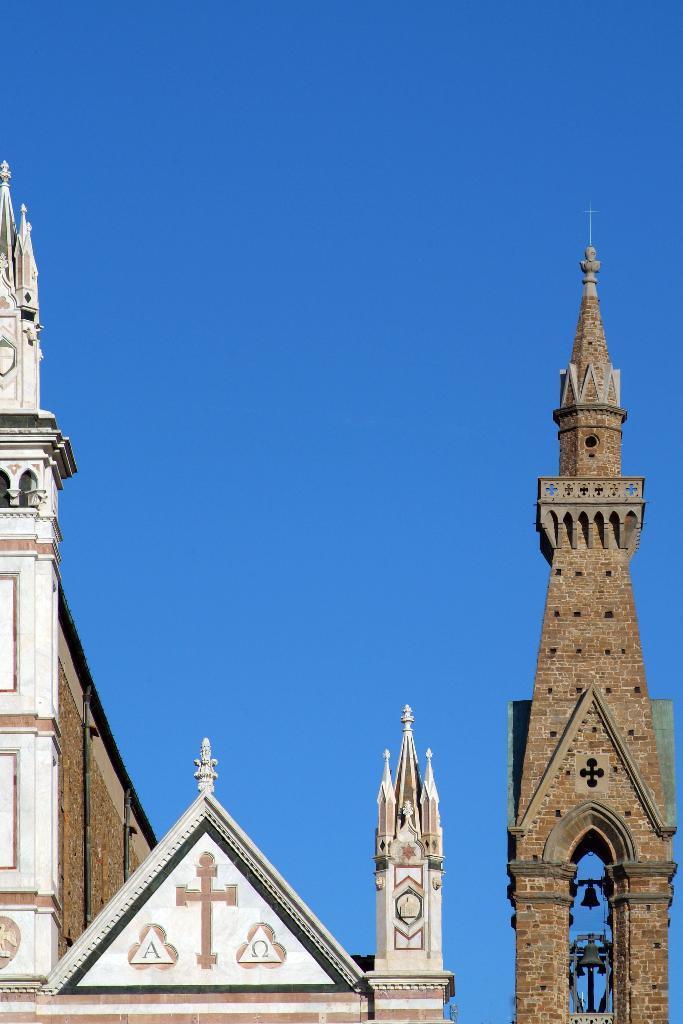Can you describe this image briefly? In this image I can see top portions of the buildings or towers, at the top of the image I can see the sky. 